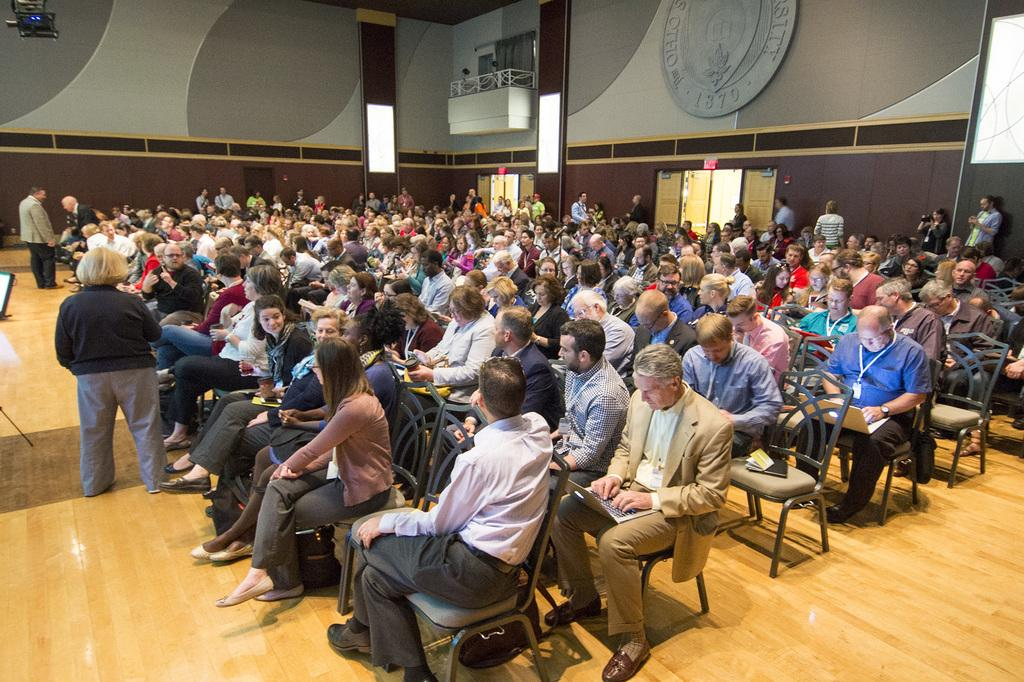What are the people in the image doing? There is a group of people sitting on chairs and a group of people standing in the image. What can be seen in the background of the image? There are walls, windows, and other objects visible in the background of the image. Can you hear the deer in the image? There are no deer present in the image, so it is not possible to hear them. 